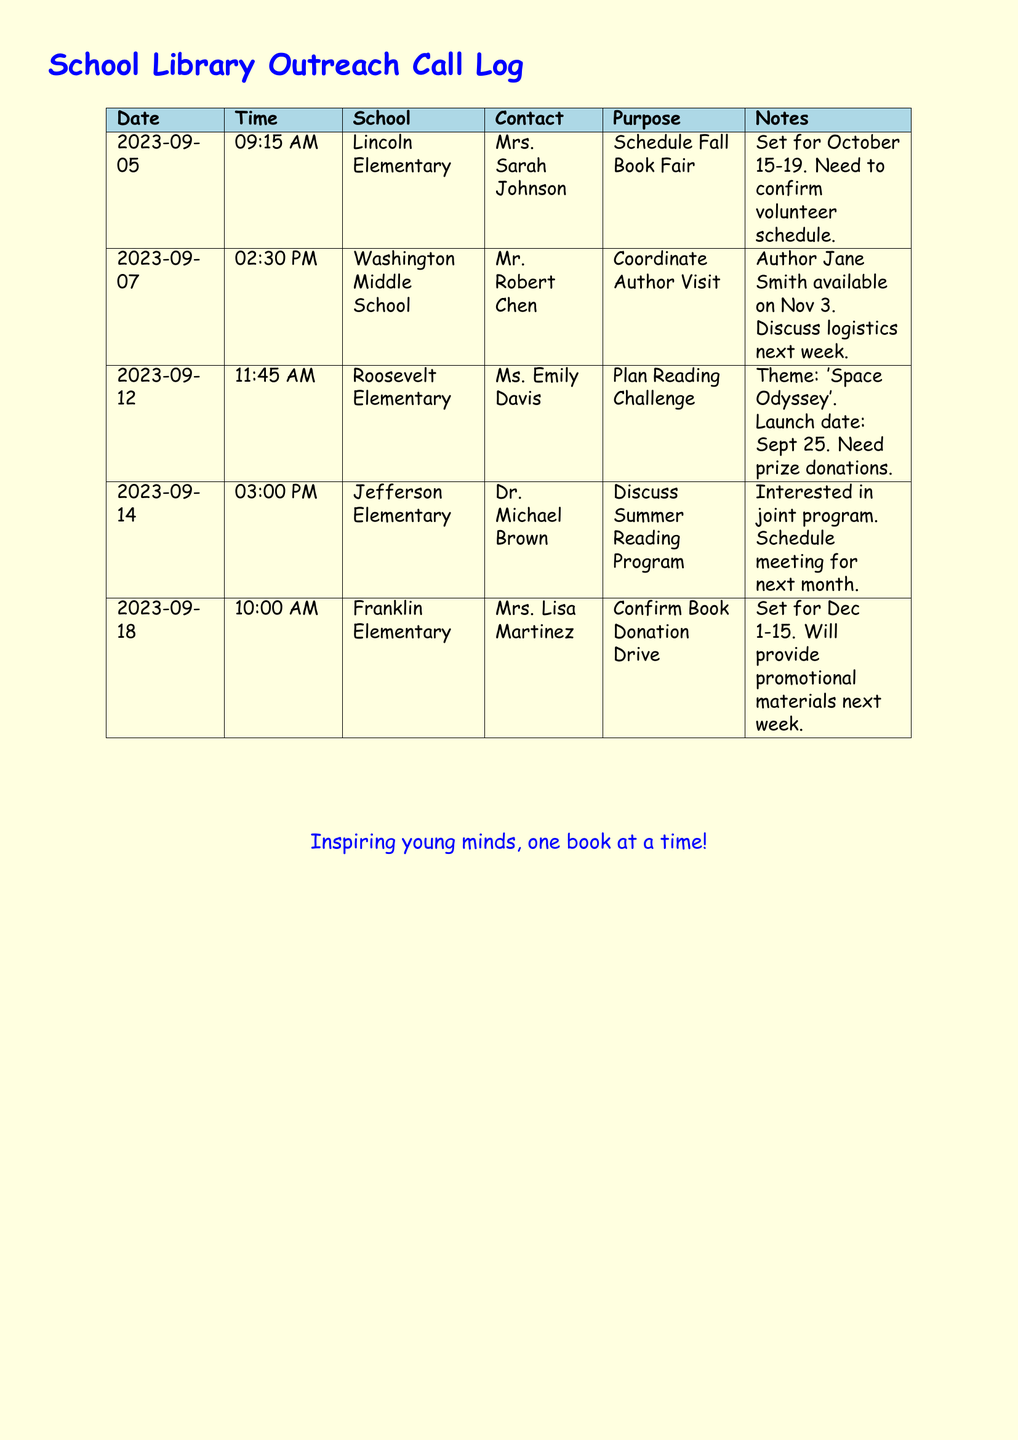What is the date of the Fall Book Fair? The Fall Book Fair is scheduled for October 15-19 as mentioned in the document.
Answer: October 15-19 Who is the contact person at Roosevelt Elementary? The contact person for Roosevelt Elementary is Ms. Emily Davis, as stated in the call log.
Answer: Ms. Emily Davis What is the theme of the upcoming Reading Challenge? The theme for the Reading Challenge is 'Space Odyssey', which is clearly noted in the document.
Answer: Space Odyssey When is the author visit scheduled? The author visit with Jane Smith is scheduled for November 3, as clarified in the document.
Answer: November 3 What is the purpose of the call to Franklin Elementary? The call to Franklin Elementary is to confirm the Book Donation Drive, as detailed in the call log.
Answer: Confirm Book Donation Drive How many schools were contacted regarding events? Five schools were contacted as listed in the call log.
Answer: Five Which school is coordinating an Author Visit? Washington Middle School is coordinating an Author Visit, according to the document.
Answer: Washington Middle School What is the launch date for the Reading Challenge? The launch date for the Reading Challenge is September 25, as indicated in the call log.
Answer: September 25 What promotional materials will be provided next week? The promotional materials for the Book Donation Drive will be provided next week, as mentioned in the document.
Answer: Promotional materials What is indicated as a need for the Reading Challenge? Prize donations are indicated as a need for the Reading Challenge, as stated in the notes.
Answer: Prize donations 